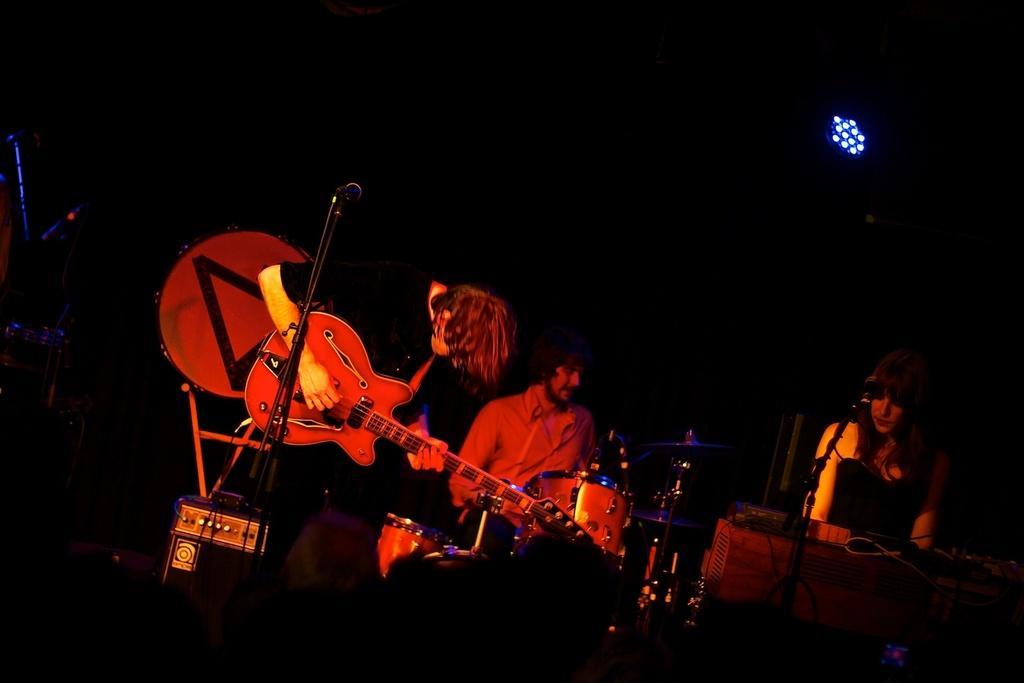Could you give a brief overview of what you see in this image? We can see a band here, this guy is holding guitar he is playing guitar we can see a microphone here, this guy here playing drums, there is a woman here she is also part of the band, these are lights yeah the right top end of the right here consists of light 